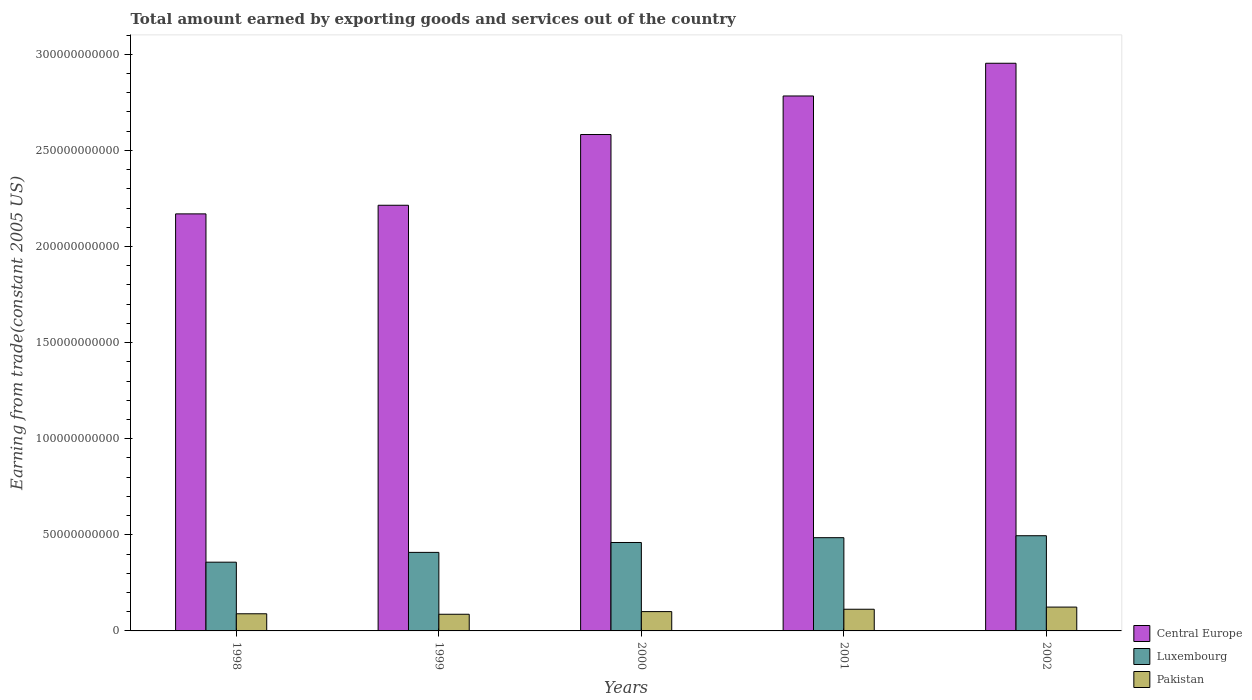How many groups of bars are there?
Your response must be concise. 5. What is the label of the 1st group of bars from the left?
Offer a very short reply. 1998. In how many cases, is the number of bars for a given year not equal to the number of legend labels?
Offer a terse response. 0. What is the total amount earned by exporting goods and services in Pakistan in 1999?
Offer a very short reply. 8.67e+09. Across all years, what is the maximum total amount earned by exporting goods and services in Pakistan?
Provide a succinct answer. 1.24e+1. Across all years, what is the minimum total amount earned by exporting goods and services in Central Europe?
Ensure brevity in your answer.  2.17e+11. In which year was the total amount earned by exporting goods and services in Central Europe maximum?
Give a very brief answer. 2002. In which year was the total amount earned by exporting goods and services in Luxembourg minimum?
Keep it short and to the point. 1998. What is the total total amount earned by exporting goods and services in Central Europe in the graph?
Your answer should be very brief. 1.27e+12. What is the difference between the total amount earned by exporting goods and services in Pakistan in 2000 and that in 2002?
Keep it short and to the point. -2.35e+09. What is the difference between the total amount earned by exporting goods and services in Central Europe in 2000 and the total amount earned by exporting goods and services in Pakistan in 2001?
Provide a succinct answer. 2.47e+11. What is the average total amount earned by exporting goods and services in Luxembourg per year?
Provide a short and direct response. 4.41e+1. In the year 2002, what is the difference between the total amount earned by exporting goods and services in Central Europe and total amount earned by exporting goods and services in Pakistan?
Make the answer very short. 2.83e+11. What is the ratio of the total amount earned by exporting goods and services in Central Europe in 1999 to that in 2002?
Offer a very short reply. 0.75. Is the total amount earned by exporting goods and services in Central Europe in 1999 less than that in 2000?
Your answer should be compact. Yes. Is the difference between the total amount earned by exporting goods and services in Central Europe in 1999 and 2002 greater than the difference between the total amount earned by exporting goods and services in Pakistan in 1999 and 2002?
Make the answer very short. No. What is the difference between the highest and the second highest total amount earned by exporting goods and services in Pakistan?
Ensure brevity in your answer.  1.12e+09. What is the difference between the highest and the lowest total amount earned by exporting goods and services in Pakistan?
Ensure brevity in your answer.  3.74e+09. In how many years, is the total amount earned by exporting goods and services in Luxembourg greater than the average total amount earned by exporting goods and services in Luxembourg taken over all years?
Provide a succinct answer. 3. What does the 2nd bar from the left in 2001 represents?
Keep it short and to the point. Luxembourg. What does the 3rd bar from the right in 2002 represents?
Make the answer very short. Central Europe. Is it the case that in every year, the sum of the total amount earned by exporting goods and services in Luxembourg and total amount earned by exporting goods and services in Central Europe is greater than the total amount earned by exporting goods and services in Pakistan?
Your answer should be very brief. Yes. Are all the bars in the graph horizontal?
Keep it short and to the point. No. Does the graph contain grids?
Keep it short and to the point. No. What is the title of the graph?
Offer a very short reply. Total amount earned by exporting goods and services out of the country. Does "Antigua and Barbuda" appear as one of the legend labels in the graph?
Offer a terse response. No. What is the label or title of the X-axis?
Make the answer very short. Years. What is the label or title of the Y-axis?
Provide a succinct answer. Earning from trade(constant 2005 US). What is the Earning from trade(constant 2005 US) of Central Europe in 1998?
Offer a very short reply. 2.17e+11. What is the Earning from trade(constant 2005 US) in Luxembourg in 1998?
Give a very brief answer. 3.58e+1. What is the Earning from trade(constant 2005 US) in Pakistan in 1998?
Keep it short and to the point. 8.92e+09. What is the Earning from trade(constant 2005 US) in Central Europe in 1999?
Make the answer very short. 2.21e+11. What is the Earning from trade(constant 2005 US) of Luxembourg in 1999?
Offer a very short reply. 4.09e+1. What is the Earning from trade(constant 2005 US) in Pakistan in 1999?
Provide a short and direct response. 8.67e+09. What is the Earning from trade(constant 2005 US) in Central Europe in 2000?
Provide a succinct answer. 2.58e+11. What is the Earning from trade(constant 2005 US) in Luxembourg in 2000?
Your response must be concise. 4.60e+1. What is the Earning from trade(constant 2005 US) in Pakistan in 2000?
Your response must be concise. 1.01e+1. What is the Earning from trade(constant 2005 US) of Central Europe in 2001?
Offer a very short reply. 2.78e+11. What is the Earning from trade(constant 2005 US) of Luxembourg in 2001?
Your answer should be very brief. 4.85e+1. What is the Earning from trade(constant 2005 US) of Pakistan in 2001?
Offer a very short reply. 1.13e+1. What is the Earning from trade(constant 2005 US) in Central Europe in 2002?
Your response must be concise. 2.95e+11. What is the Earning from trade(constant 2005 US) in Luxembourg in 2002?
Your answer should be compact. 4.95e+1. What is the Earning from trade(constant 2005 US) in Pakistan in 2002?
Ensure brevity in your answer.  1.24e+1. Across all years, what is the maximum Earning from trade(constant 2005 US) in Central Europe?
Your answer should be compact. 2.95e+11. Across all years, what is the maximum Earning from trade(constant 2005 US) of Luxembourg?
Keep it short and to the point. 4.95e+1. Across all years, what is the maximum Earning from trade(constant 2005 US) of Pakistan?
Provide a short and direct response. 1.24e+1. Across all years, what is the minimum Earning from trade(constant 2005 US) in Central Europe?
Your answer should be very brief. 2.17e+11. Across all years, what is the minimum Earning from trade(constant 2005 US) in Luxembourg?
Offer a very short reply. 3.58e+1. Across all years, what is the minimum Earning from trade(constant 2005 US) of Pakistan?
Your response must be concise. 8.67e+09. What is the total Earning from trade(constant 2005 US) in Central Europe in the graph?
Your answer should be very brief. 1.27e+12. What is the total Earning from trade(constant 2005 US) in Luxembourg in the graph?
Provide a short and direct response. 2.21e+11. What is the total Earning from trade(constant 2005 US) of Pakistan in the graph?
Offer a very short reply. 5.13e+1. What is the difference between the Earning from trade(constant 2005 US) of Central Europe in 1998 and that in 1999?
Offer a very short reply. -4.49e+09. What is the difference between the Earning from trade(constant 2005 US) in Luxembourg in 1998 and that in 1999?
Ensure brevity in your answer.  -5.10e+09. What is the difference between the Earning from trade(constant 2005 US) in Pakistan in 1998 and that in 1999?
Your response must be concise. 2.54e+08. What is the difference between the Earning from trade(constant 2005 US) in Central Europe in 1998 and that in 2000?
Your answer should be compact. -4.13e+1. What is the difference between the Earning from trade(constant 2005 US) in Luxembourg in 1998 and that in 2000?
Offer a terse response. -1.02e+1. What is the difference between the Earning from trade(constant 2005 US) of Pakistan in 1998 and that in 2000?
Offer a very short reply. -1.13e+09. What is the difference between the Earning from trade(constant 2005 US) of Central Europe in 1998 and that in 2001?
Ensure brevity in your answer.  -6.13e+1. What is the difference between the Earning from trade(constant 2005 US) of Luxembourg in 1998 and that in 2001?
Your answer should be very brief. -1.28e+1. What is the difference between the Earning from trade(constant 2005 US) of Pakistan in 1998 and that in 2001?
Your response must be concise. -2.36e+09. What is the difference between the Earning from trade(constant 2005 US) in Central Europe in 1998 and that in 2002?
Provide a short and direct response. -7.84e+1. What is the difference between the Earning from trade(constant 2005 US) in Luxembourg in 1998 and that in 2002?
Offer a terse response. -1.38e+1. What is the difference between the Earning from trade(constant 2005 US) in Pakistan in 1998 and that in 2002?
Offer a terse response. -3.48e+09. What is the difference between the Earning from trade(constant 2005 US) in Central Europe in 1999 and that in 2000?
Your answer should be compact. -3.68e+1. What is the difference between the Earning from trade(constant 2005 US) of Luxembourg in 1999 and that in 2000?
Ensure brevity in your answer.  -5.15e+09. What is the difference between the Earning from trade(constant 2005 US) of Pakistan in 1999 and that in 2000?
Your response must be concise. -1.39e+09. What is the difference between the Earning from trade(constant 2005 US) of Central Europe in 1999 and that in 2001?
Keep it short and to the point. -5.69e+1. What is the difference between the Earning from trade(constant 2005 US) in Luxembourg in 1999 and that in 2001?
Offer a very short reply. -7.65e+09. What is the difference between the Earning from trade(constant 2005 US) in Pakistan in 1999 and that in 2001?
Keep it short and to the point. -2.61e+09. What is the difference between the Earning from trade(constant 2005 US) of Central Europe in 1999 and that in 2002?
Offer a terse response. -7.39e+1. What is the difference between the Earning from trade(constant 2005 US) in Luxembourg in 1999 and that in 2002?
Give a very brief answer. -8.67e+09. What is the difference between the Earning from trade(constant 2005 US) in Pakistan in 1999 and that in 2002?
Offer a terse response. -3.74e+09. What is the difference between the Earning from trade(constant 2005 US) in Central Europe in 2000 and that in 2001?
Offer a terse response. -2.01e+1. What is the difference between the Earning from trade(constant 2005 US) in Luxembourg in 2000 and that in 2001?
Your response must be concise. -2.51e+09. What is the difference between the Earning from trade(constant 2005 US) of Pakistan in 2000 and that in 2001?
Offer a very short reply. -1.22e+09. What is the difference between the Earning from trade(constant 2005 US) of Central Europe in 2000 and that in 2002?
Keep it short and to the point. -3.71e+1. What is the difference between the Earning from trade(constant 2005 US) of Luxembourg in 2000 and that in 2002?
Ensure brevity in your answer.  -3.52e+09. What is the difference between the Earning from trade(constant 2005 US) in Pakistan in 2000 and that in 2002?
Offer a terse response. -2.35e+09. What is the difference between the Earning from trade(constant 2005 US) in Central Europe in 2001 and that in 2002?
Offer a terse response. -1.70e+1. What is the difference between the Earning from trade(constant 2005 US) of Luxembourg in 2001 and that in 2002?
Your response must be concise. -1.02e+09. What is the difference between the Earning from trade(constant 2005 US) of Pakistan in 2001 and that in 2002?
Your answer should be very brief. -1.12e+09. What is the difference between the Earning from trade(constant 2005 US) in Central Europe in 1998 and the Earning from trade(constant 2005 US) in Luxembourg in 1999?
Offer a very short reply. 1.76e+11. What is the difference between the Earning from trade(constant 2005 US) in Central Europe in 1998 and the Earning from trade(constant 2005 US) in Pakistan in 1999?
Your answer should be compact. 2.08e+11. What is the difference between the Earning from trade(constant 2005 US) of Luxembourg in 1998 and the Earning from trade(constant 2005 US) of Pakistan in 1999?
Your response must be concise. 2.71e+1. What is the difference between the Earning from trade(constant 2005 US) of Central Europe in 1998 and the Earning from trade(constant 2005 US) of Luxembourg in 2000?
Make the answer very short. 1.71e+11. What is the difference between the Earning from trade(constant 2005 US) of Central Europe in 1998 and the Earning from trade(constant 2005 US) of Pakistan in 2000?
Offer a terse response. 2.07e+11. What is the difference between the Earning from trade(constant 2005 US) in Luxembourg in 1998 and the Earning from trade(constant 2005 US) in Pakistan in 2000?
Provide a short and direct response. 2.57e+1. What is the difference between the Earning from trade(constant 2005 US) in Central Europe in 1998 and the Earning from trade(constant 2005 US) in Luxembourg in 2001?
Make the answer very short. 1.68e+11. What is the difference between the Earning from trade(constant 2005 US) in Central Europe in 1998 and the Earning from trade(constant 2005 US) in Pakistan in 2001?
Give a very brief answer. 2.06e+11. What is the difference between the Earning from trade(constant 2005 US) in Luxembourg in 1998 and the Earning from trade(constant 2005 US) in Pakistan in 2001?
Offer a terse response. 2.45e+1. What is the difference between the Earning from trade(constant 2005 US) of Central Europe in 1998 and the Earning from trade(constant 2005 US) of Luxembourg in 2002?
Offer a terse response. 1.67e+11. What is the difference between the Earning from trade(constant 2005 US) in Central Europe in 1998 and the Earning from trade(constant 2005 US) in Pakistan in 2002?
Give a very brief answer. 2.05e+11. What is the difference between the Earning from trade(constant 2005 US) of Luxembourg in 1998 and the Earning from trade(constant 2005 US) of Pakistan in 2002?
Provide a succinct answer. 2.34e+1. What is the difference between the Earning from trade(constant 2005 US) of Central Europe in 1999 and the Earning from trade(constant 2005 US) of Luxembourg in 2000?
Provide a succinct answer. 1.75e+11. What is the difference between the Earning from trade(constant 2005 US) of Central Europe in 1999 and the Earning from trade(constant 2005 US) of Pakistan in 2000?
Offer a terse response. 2.11e+11. What is the difference between the Earning from trade(constant 2005 US) in Luxembourg in 1999 and the Earning from trade(constant 2005 US) in Pakistan in 2000?
Ensure brevity in your answer.  3.08e+1. What is the difference between the Earning from trade(constant 2005 US) in Central Europe in 1999 and the Earning from trade(constant 2005 US) in Luxembourg in 2001?
Offer a terse response. 1.73e+11. What is the difference between the Earning from trade(constant 2005 US) in Central Europe in 1999 and the Earning from trade(constant 2005 US) in Pakistan in 2001?
Provide a short and direct response. 2.10e+11. What is the difference between the Earning from trade(constant 2005 US) of Luxembourg in 1999 and the Earning from trade(constant 2005 US) of Pakistan in 2001?
Offer a very short reply. 2.96e+1. What is the difference between the Earning from trade(constant 2005 US) in Central Europe in 1999 and the Earning from trade(constant 2005 US) in Luxembourg in 2002?
Offer a very short reply. 1.72e+11. What is the difference between the Earning from trade(constant 2005 US) of Central Europe in 1999 and the Earning from trade(constant 2005 US) of Pakistan in 2002?
Provide a succinct answer. 2.09e+11. What is the difference between the Earning from trade(constant 2005 US) in Luxembourg in 1999 and the Earning from trade(constant 2005 US) in Pakistan in 2002?
Your answer should be very brief. 2.85e+1. What is the difference between the Earning from trade(constant 2005 US) of Central Europe in 2000 and the Earning from trade(constant 2005 US) of Luxembourg in 2001?
Keep it short and to the point. 2.10e+11. What is the difference between the Earning from trade(constant 2005 US) in Central Europe in 2000 and the Earning from trade(constant 2005 US) in Pakistan in 2001?
Provide a succinct answer. 2.47e+11. What is the difference between the Earning from trade(constant 2005 US) of Luxembourg in 2000 and the Earning from trade(constant 2005 US) of Pakistan in 2001?
Your response must be concise. 3.47e+1. What is the difference between the Earning from trade(constant 2005 US) of Central Europe in 2000 and the Earning from trade(constant 2005 US) of Luxembourg in 2002?
Your answer should be very brief. 2.09e+11. What is the difference between the Earning from trade(constant 2005 US) of Central Europe in 2000 and the Earning from trade(constant 2005 US) of Pakistan in 2002?
Offer a very short reply. 2.46e+11. What is the difference between the Earning from trade(constant 2005 US) of Luxembourg in 2000 and the Earning from trade(constant 2005 US) of Pakistan in 2002?
Your answer should be compact. 3.36e+1. What is the difference between the Earning from trade(constant 2005 US) of Central Europe in 2001 and the Earning from trade(constant 2005 US) of Luxembourg in 2002?
Offer a very short reply. 2.29e+11. What is the difference between the Earning from trade(constant 2005 US) in Central Europe in 2001 and the Earning from trade(constant 2005 US) in Pakistan in 2002?
Provide a succinct answer. 2.66e+11. What is the difference between the Earning from trade(constant 2005 US) of Luxembourg in 2001 and the Earning from trade(constant 2005 US) of Pakistan in 2002?
Your answer should be compact. 3.61e+1. What is the average Earning from trade(constant 2005 US) of Central Europe per year?
Offer a terse response. 2.54e+11. What is the average Earning from trade(constant 2005 US) of Luxembourg per year?
Offer a terse response. 4.41e+1. What is the average Earning from trade(constant 2005 US) in Pakistan per year?
Keep it short and to the point. 1.03e+1. In the year 1998, what is the difference between the Earning from trade(constant 2005 US) in Central Europe and Earning from trade(constant 2005 US) in Luxembourg?
Provide a succinct answer. 1.81e+11. In the year 1998, what is the difference between the Earning from trade(constant 2005 US) in Central Europe and Earning from trade(constant 2005 US) in Pakistan?
Your answer should be compact. 2.08e+11. In the year 1998, what is the difference between the Earning from trade(constant 2005 US) in Luxembourg and Earning from trade(constant 2005 US) in Pakistan?
Provide a short and direct response. 2.68e+1. In the year 1999, what is the difference between the Earning from trade(constant 2005 US) in Central Europe and Earning from trade(constant 2005 US) in Luxembourg?
Give a very brief answer. 1.81e+11. In the year 1999, what is the difference between the Earning from trade(constant 2005 US) of Central Europe and Earning from trade(constant 2005 US) of Pakistan?
Offer a terse response. 2.13e+11. In the year 1999, what is the difference between the Earning from trade(constant 2005 US) of Luxembourg and Earning from trade(constant 2005 US) of Pakistan?
Your answer should be very brief. 3.22e+1. In the year 2000, what is the difference between the Earning from trade(constant 2005 US) of Central Europe and Earning from trade(constant 2005 US) of Luxembourg?
Your answer should be very brief. 2.12e+11. In the year 2000, what is the difference between the Earning from trade(constant 2005 US) of Central Europe and Earning from trade(constant 2005 US) of Pakistan?
Your answer should be very brief. 2.48e+11. In the year 2000, what is the difference between the Earning from trade(constant 2005 US) of Luxembourg and Earning from trade(constant 2005 US) of Pakistan?
Ensure brevity in your answer.  3.59e+1. In the year 2001, what is the difference between the Earning from trade(constant 2005 US) of Central Europe and Earning from trade(constant 2005 US) of Luxembourg?
Provide a succinct answer. 2.30e+11. In the year 2001, what is the difference between the Earning from trade(constant 2005 US) in Central Europe and Earning from trade(constant 2005 US) in Pakistan?
Offer a terse response. 2.67e+11. In the year 2001, what is the difference between the Earning from trade(constant 2005 US) of Luxembourg and Earning from trade(constant 2005 US) of Pakistan?
Offer a very short reply. 3.72e+1. In the year 2002, what is the difference between the Earning from trade(constant 2005 US) in Central Europe and Earning from trade(constant 2005 US) in Luxembourg?
Your answer should be very brief. 2.46e+11. In the year 2002, what is the difference between the Earning from trade(constant 2005 US) in Central Europe and Earning from trade(constant 2005 US) in Pakistan?
Keep it short and to the point. 2.83e+11. In the year 2002, what is the difference between the Earning from trade(constant 2005 US) in Luxembourg and Earning from trade(constant 2005 US) in Pakistan?
Make the answer very short. 3.71e+1. What is the ratio of the Earning from trade(constant 2005 US) in Central Europe in 1998 to that in 1999?
Make the answer very short. 0.98. What is the ratio of the Earning from trade(constant 2005 US) of Luxembourg in 1998 to that in 1999?
Provide a succinct answer. 0.88. What is the ratio of the Earning from trade(constant 2005 US) of Pakistan in 1998 to that in 1999?
Offer a terse response. 1.03. What is the ratio of the Earning from trade(constant 2005 US) of Central Europe in 1998 to that in 2000?
Your answer should be compact. 0.84. What is the ratio of the Earning from trade(constant 2005 US) of Luxembourg in 1998 to that in 2000?
Ensure brevity in your answer.  0.78. What is the ratio of the Earning from trade(constant 2005 US) in Pakistan in 1998 to that in 2000?
Provide a short and direct response. 0.89. What is the ratio of the Earning from trade(constant 2005 US) in Central Europe in 1998 to that in 2001?
Your answer should be compact. 0.78. What is the ratio of the Earning from trade(constant 2005 US) of Luxembourg in 1998 to that in 2001?
Make the answer very short. 0.74. What is the ratio of the Earning from trade(constant 2005 US) in Pakistan in 1998 to that in 2001?
Offer a very short reply. 0.79. What is the ratio of the Earning from trade(constant 2005 US) in Central Europe in 1998 to that in 2002?
Keep it short and to the point. 0.73. What is the ratio of the Earning from trade(constant 2005 US) in Luxembourg in 1998 to that in 2002?
Your answer should be compact. 0.72. What is the ratio of the Earning from trade(constant 2005 US) of Pakistan in 1998 to that in 2002?
Make the answer very short. 0.72. What is the ratio of the Earning from trade(constant 2005 US) in Central Europe in 1999 to that in 2000?
Provide a short and direct response. 0.86. What is the ratio of the Earning from trade(constant 2005 US) in Luxembourg in 1999 to that in 2000?
Offer a terse response. 0.89. What is the ratio of the Earning from trade(constant 2005 US) in Pakistan in 1999 to that in 2000?
Provide a succinct answer. 0.86. What is the ratio of the Earning from trade(constant 2005 US) in Central Europe in 1999 to that in 2001?
Your answer should be very brief. 0.8. What is the ratio of the Earning from trade(constant 2005 US) of Luxembourg in 1999 to that in 2001?
Your response must be concise. 0.84. What is the ratio of the Earning from trade(constant 2005 US) of Pakistan in 1999 to that in 2001?
Offer a very short reply. 0.77. What is the ratio of the Earning from trade(constant 2005 US) in Central Europe in 1999 to that in 2002?
Ensure brevity in your answer.  0.75. What is the ratio of the Earning from trade(constant 2005 US) in Luxembourg in 1999 to that in 2002?
Your response must be concise. 0.82. What is the ratio of the Earning from trade(constant 2005 US) in Pakistan in 1999 to that in 2002?
Provide a succinct answer. 0.7. What is the ratio of the Earning from trade(constant 2005 US) in Central Europe in 2000 to that in 2001?
Keep it short and to the point. 0.93. What is the ratio of the Earning from trade(constant 2005 US) of Luxembourg in 2000 to that in 2001?
Give a very brief answer. 0.95. What is the ratio of the Earning from trade(constant 2005 US) of Pakistan in 2000 to that in 2001?
Your answer should be very brief. 0.89. What is the ratio of the Earning from trade(constant 2005 US) in Central Europe in 2000 to that in 2002?
Keep it short and to the point. 0.87. What is the ratio of the Earning from trade(constant 2005 US) of Luxembourg in 2000 to that in 2002?
Your answer should be very brief. 0.93. What is the ratio of the Earning from trade(constant 2005 US) in Pakistan in 2000 to that in 2002?
Make the answer very short. 0.81. What is the ratio of the Earning from trade(constant 2005 US) in Central Europe in 2001 to that in 2002?
Give a very brief answer. 0.94. What is the ratio of the Earning from trade(constant 2005 US) in Luxembourg in 2001 to that in 2002?
Make the answer very short. 0.98. What is the ratio of the Earning from trade(constant 2005 US) of Pakistan in 2001 to that in 2002?
Keep it short and to the point. 0.91. What is the difference between the highest and the second highest Earning from trade(constant 2005 US) of Central Europe?
Your answer should be compact. 1.70e+1. What is the difference between the highest and the second highest Earning from trade(constant 2005 US) of Luxembourg?
Give a very brief answer. 1.02e+09. What is the difference between the highest and the second highest Earning from trade(constant 2005 US) in Pakistan?
Keep it short and to the point. 1.12e+09. What is the difference between the highest and the lowest Earning from trade(constant 2005 US) of Central Europe?
Your answer should be compact. 7.84e+1. What is the difference between the highest and the lowest Earning from trade(constant 2005 US) in Luxembourg?
Provide a succinct answer. 1.38e+1. What is the difference between the highest and the lowest Earning from trade(constant 2005 US) in Pakistan?
Your answer should be very brief. 3.74e+09. 